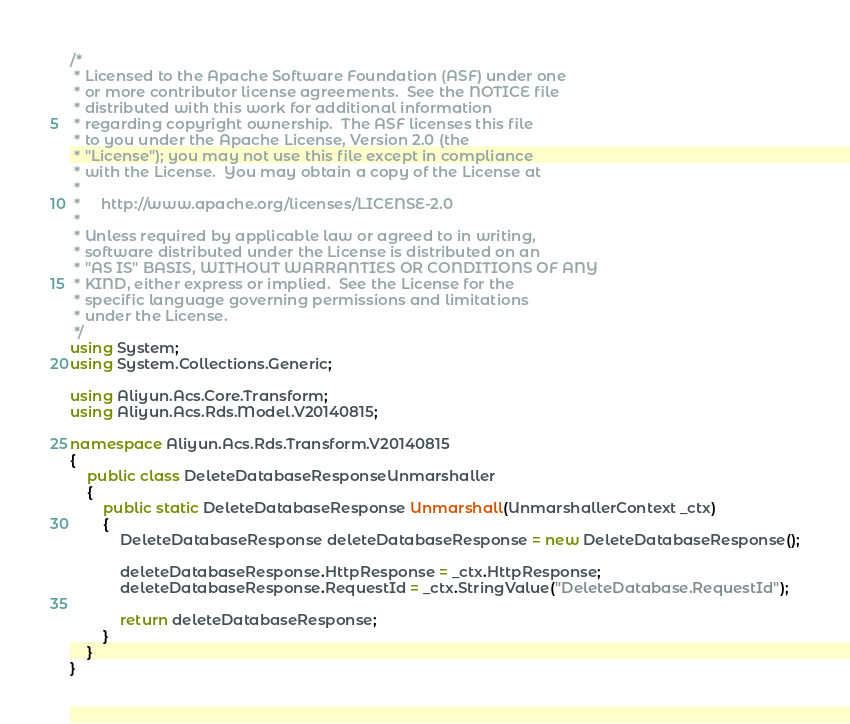<code> <loc_0><loc_0><loc_500><loc_500><_C#_>/*
 * Licensed to the Apache Software Foundation (ASF) under one
 * or more contributor license agreements.  See the NOTICE file
 * distributed with this work for additional information
 * regarding copyright ownership.  The ASF licenses this file
 * to you under the Apache License, Version 2.0 (the
 * "License"); you may not use this file except in compliance
 * with the License.  You may obtain a copy of the License at
 *
 *     http://www.apache.org/licenses/LICENSE-2.0
 *
 * Unless required by applicable law or agreed to in writing,
 * software distributed under the License is distributed on an
 * "AS IS" BASIS, WITHOUT WARRANTIES OR CONDITIONS OF ANY
 * KIND, either express or implied.  See the License for the
 * specific language governing permissions and limitations
 * under the License.
 */
using System;
using System.Collections.Generic;

using Aliyun.Acs.Core.Transform;
using Aliyun.Acs.Rds.Model.V20140815;

namespace Aliyun.Acs.Rds.Transform.V20140815
{
    public class DeleteDatabaseResponseUnmarshaller
    {
        public static DeleteDatabaseResponse Unmarshall(UnmarshallerContext _ctx)
        {
			DeleteDatabaseResponse deleteDatabaseResponse = new DeleteDatabaseResponse();

			deleteDatabaseResponse.HttpResponse = _ctx.HttpResponse;
			deleteDatabaseResponse.RequestId = _ctx.StringValue("DeleteDatabase.RequestId");
        
			return deleteDatabaseResponse;
        }
    }
}
</code> 